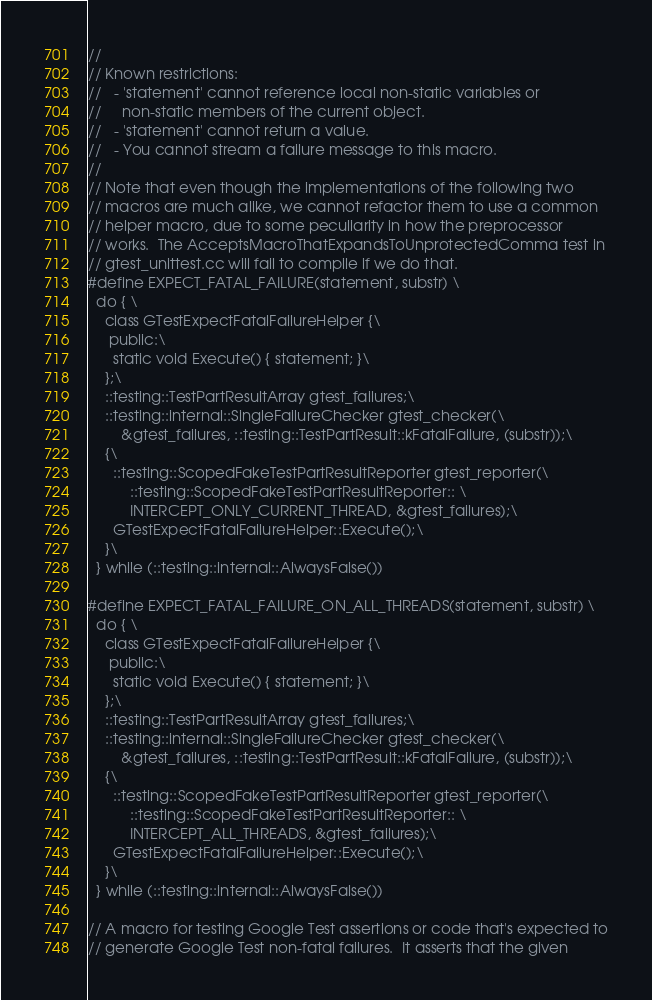Convert code to text. <code><loc_0><loc_0><loc_500><loc_500><_C++_>//
// Known restrictions:
//   - 'statement' cannot reference local non-static variables or
//     non-static members of the current object.
//   - 'statement' cannot return a value.
//   - You cannot stream a failure message to this macro.
//
// Note that even though the implementations of the following two
// macros are much alike, we cannot refactor them to use a common
// helper macro, due to some peculiarity in how the preprocessor
// works.  The AcceptsMacroThatExpandsToUnprotectedComma test in
// gtest_unittest.cc will fail to compile if we do that.
#define EXPECT_FATAL_FAILURE(statement, substr) \
  do { \
    class GTestExpectFatalFailureHelper {\
     public:\
      static void Execute() { statement; }\
    };\
    ::testing::TestPartResultArray gtest_failures;\
    ::testing::internal::SingleFailureChecker gtest_checker(\
        &gtest_failures, ::testing::TestPartResult::kFatalFailure, (substr));\
    {\
      ::testing::ScopedFakeTestPartResultReporter gtest_reporter(\
          ::testing::ScopedFakeTestPartResultReporter:: \
          INTERCEPT_ONLY_CURRENT_THREAD, &gtest_failures);\
      GTestExpectFatalFailureHelper::Execute();\
    }\
  } while (::testing::internal::AlwaysFalse())

#define EXPECT_FATAL_FAILURE_ON_ALL_THREADS(statement, substr) \
  do { \
    class GTestExpectFatalFailureHelper {\
     public:\
      static void Execute() { statement; }\
    };\
    ::testing::TestPartResultArray gtest_failures;\
    ::testing::internal::SingleFailureChecker gtest_checker(\
        &gtest_failures, ::testing::TestPartResult::kFatalFailure, (substr));\
    {\
      ::testing::ScopedFakeTestPartResultReporter gtest_reporter(\
          ::testing::ScopedFakeTestPartResultReporter:: \
          INTERCEPT_ALL_THREADS, &gtest_failures);\
      GTestExpectFatalFailureHelper::Execute();\
    }\
  } while (::testing::internal::AlwaysFalse())

// A macro for testing Google Test assertions or code that's expected to
// generate Google Test non-fatal failures.  It asserts that the given</code> 